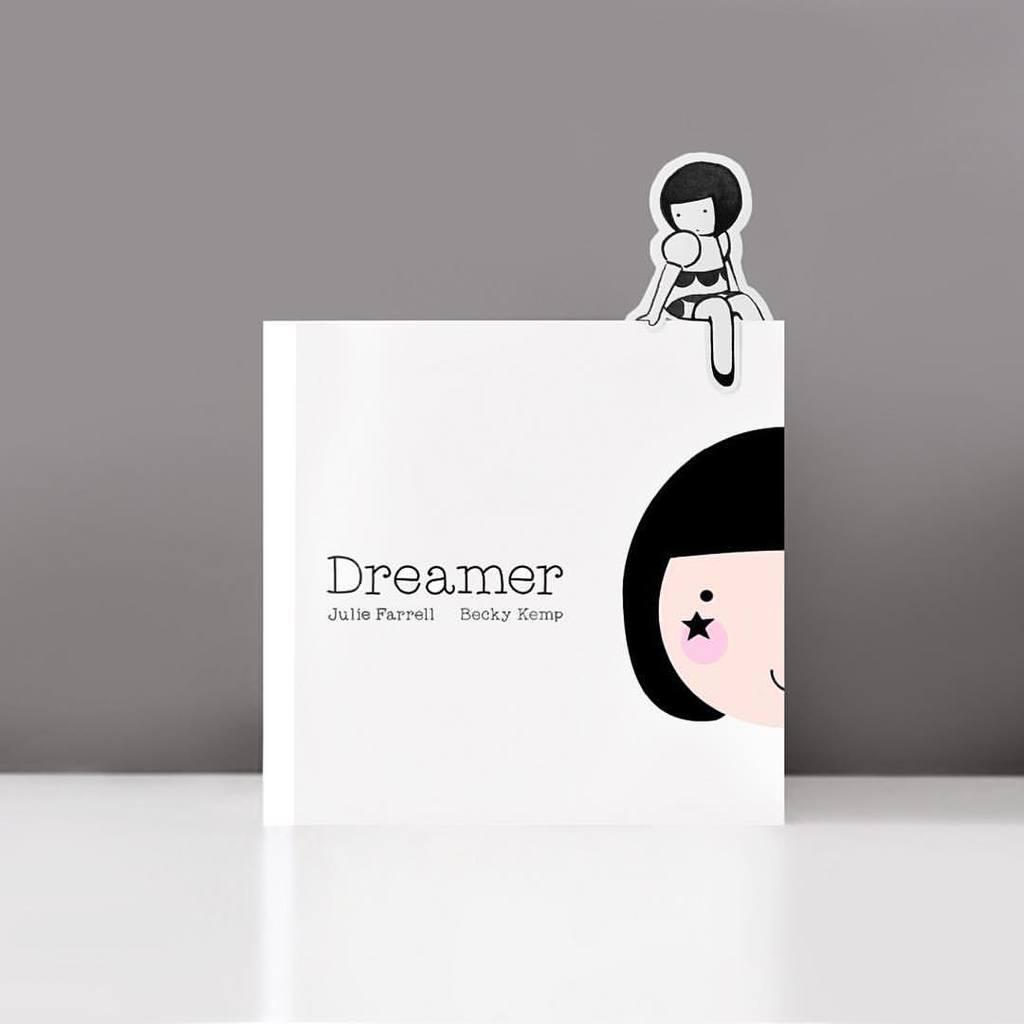Please provide a concise description of this image. In this image in the front there is a text written on the image and on the top of the text there is an animated image. 